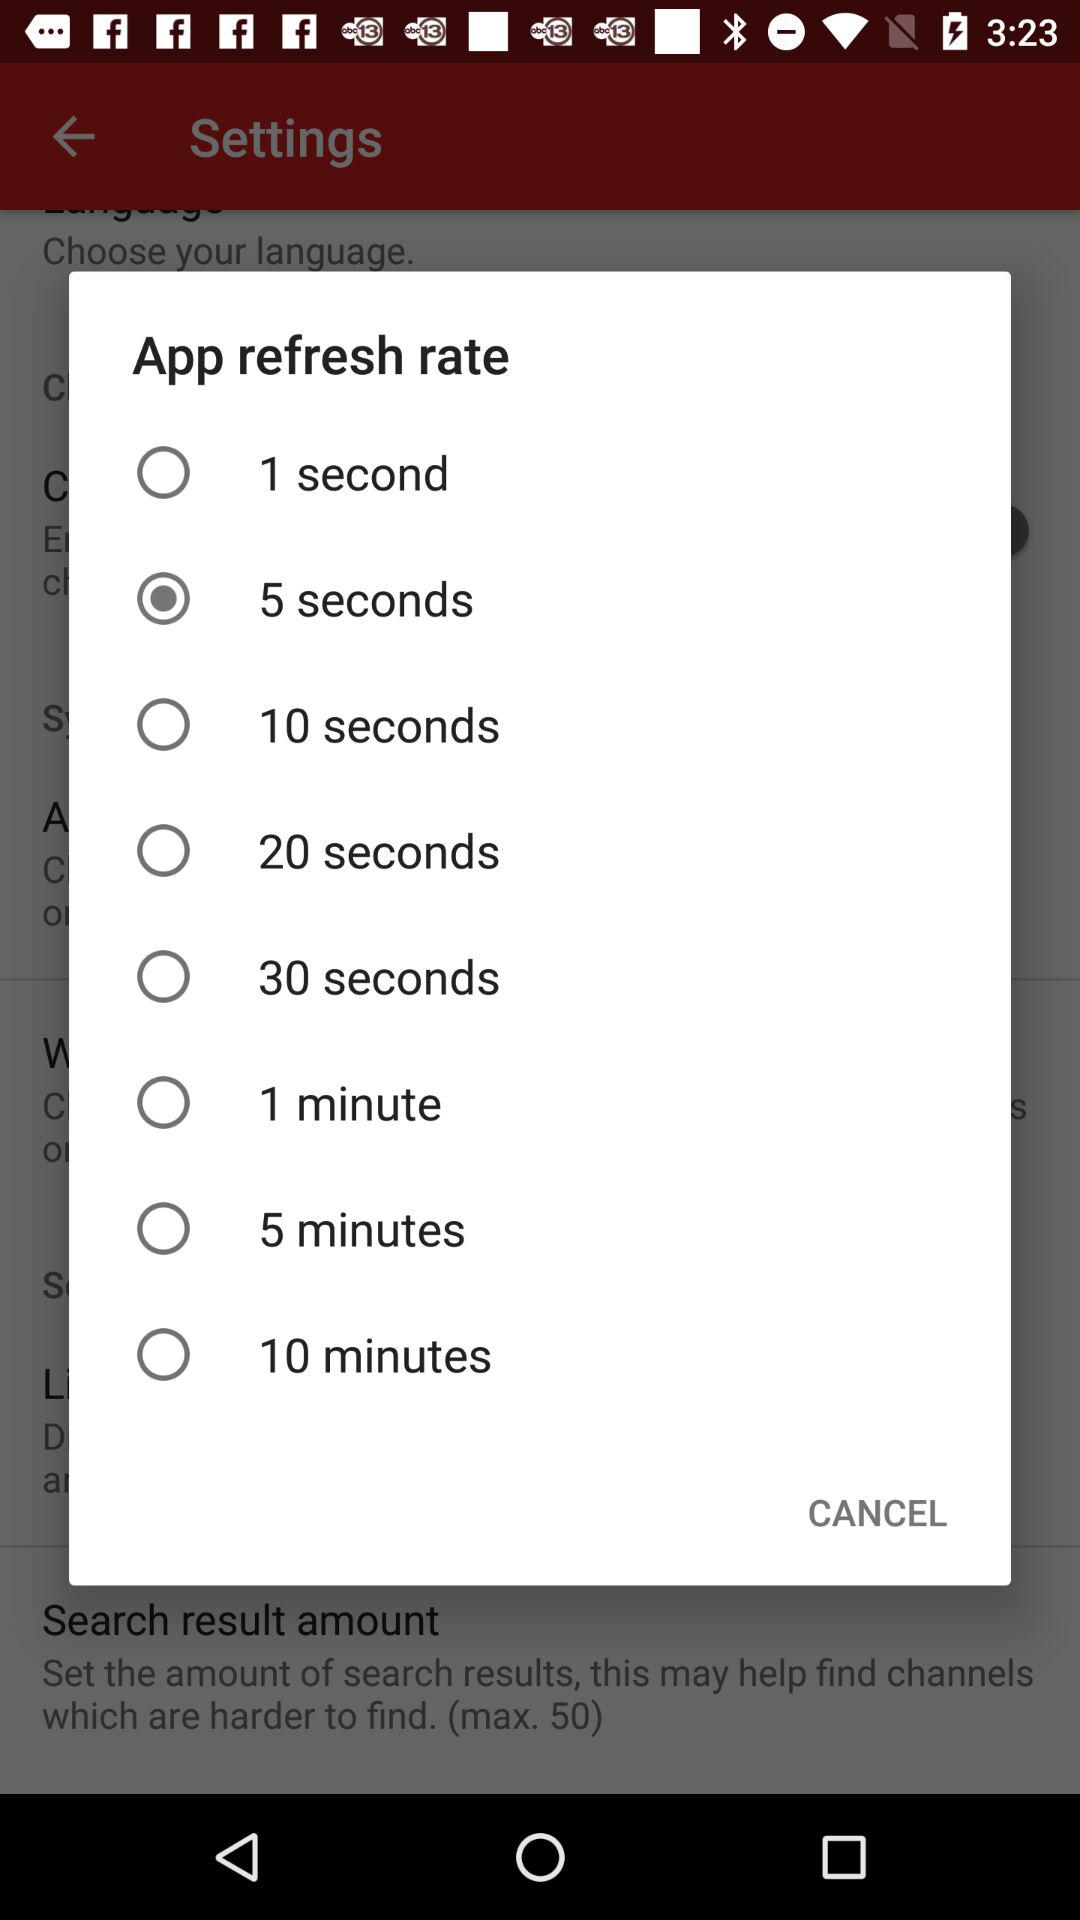How many refresh rates are there?
Answer the question using a single word or phrase. 8 